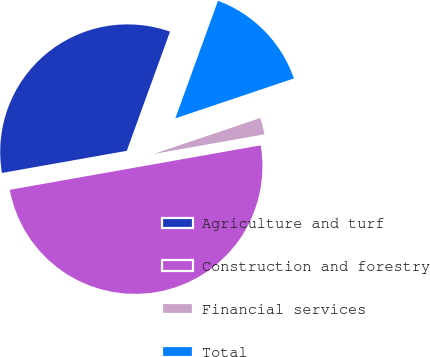Convert chart to OTSL. <chart><loc_0><loc_0><loc_500><loc_500><pie_chart><fcel>Agriculture and turf<fcel>Construction and forestry<fcel>Financial services<fcel>Total<nl><fcel>33.33%<fcel>50.0%<fcel>2.38%<fcel>14.29%<nl></chart> 